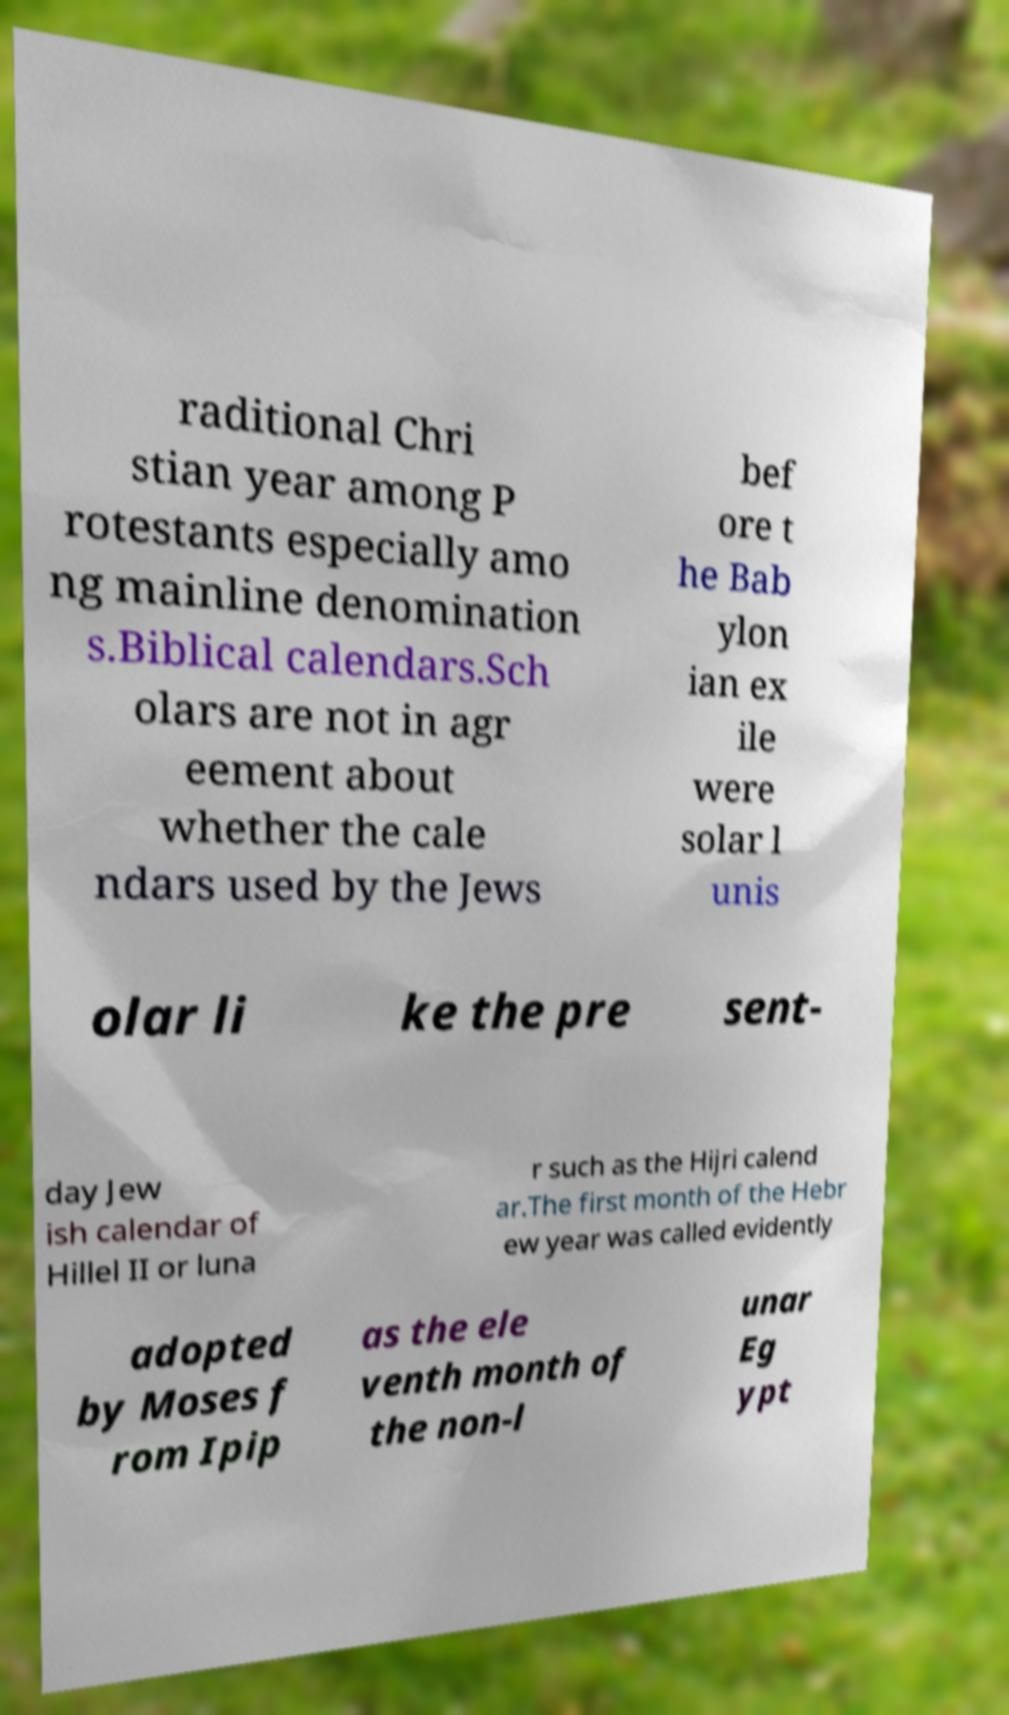Please read and relay the text visible in this image. What does it say? raditional Chri stian year among P rotestants especially amo ng mainline denomination s.Biblical calendars.Sch olars are not in agr eement about whether the cale ndars used by the Jews bef ore t he Bab ylon ian ex ile were solar l unis olar li ke the pre sent- day Jew ish calendar of Hillel II or luna r such as the Hijri calend ar.The first month of the Hebr ew year was called evidently adopted by Moses f rom Ipip as the ele venth month of the non-l unar Eg ypt 